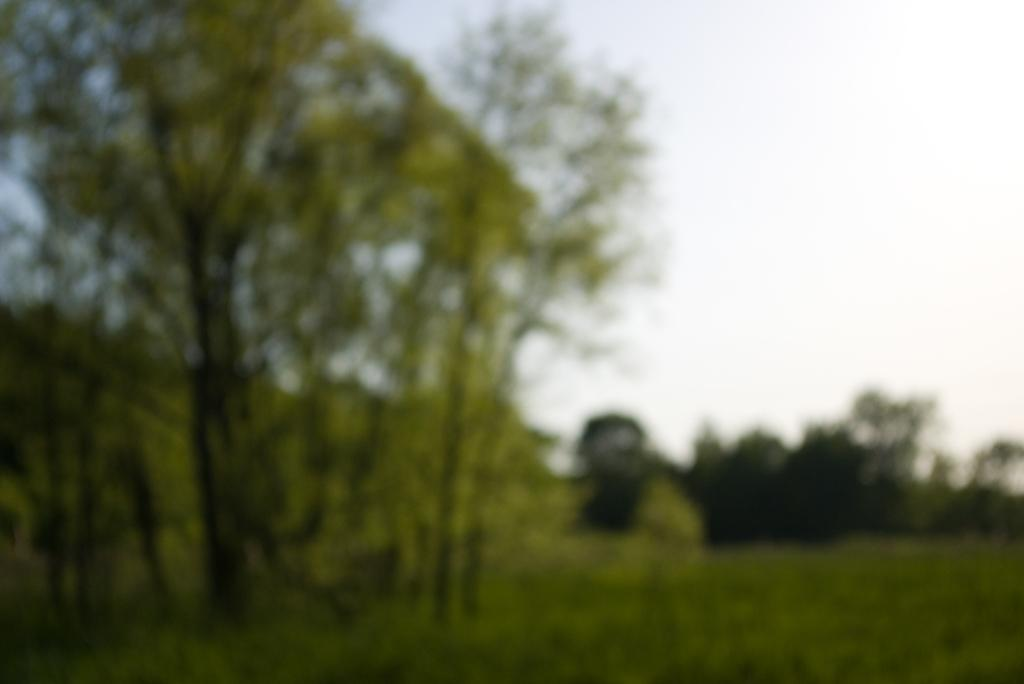What type of vegetation can be seen in the image? There is grass visible in the image. What can be seen in the background of the image? There are trees and the sky visible in the background of the image. What type of lace is being used to decorate the maid's uniform in the image? There is no maid or lace present in the image; it features grass, trees, and the sky. 